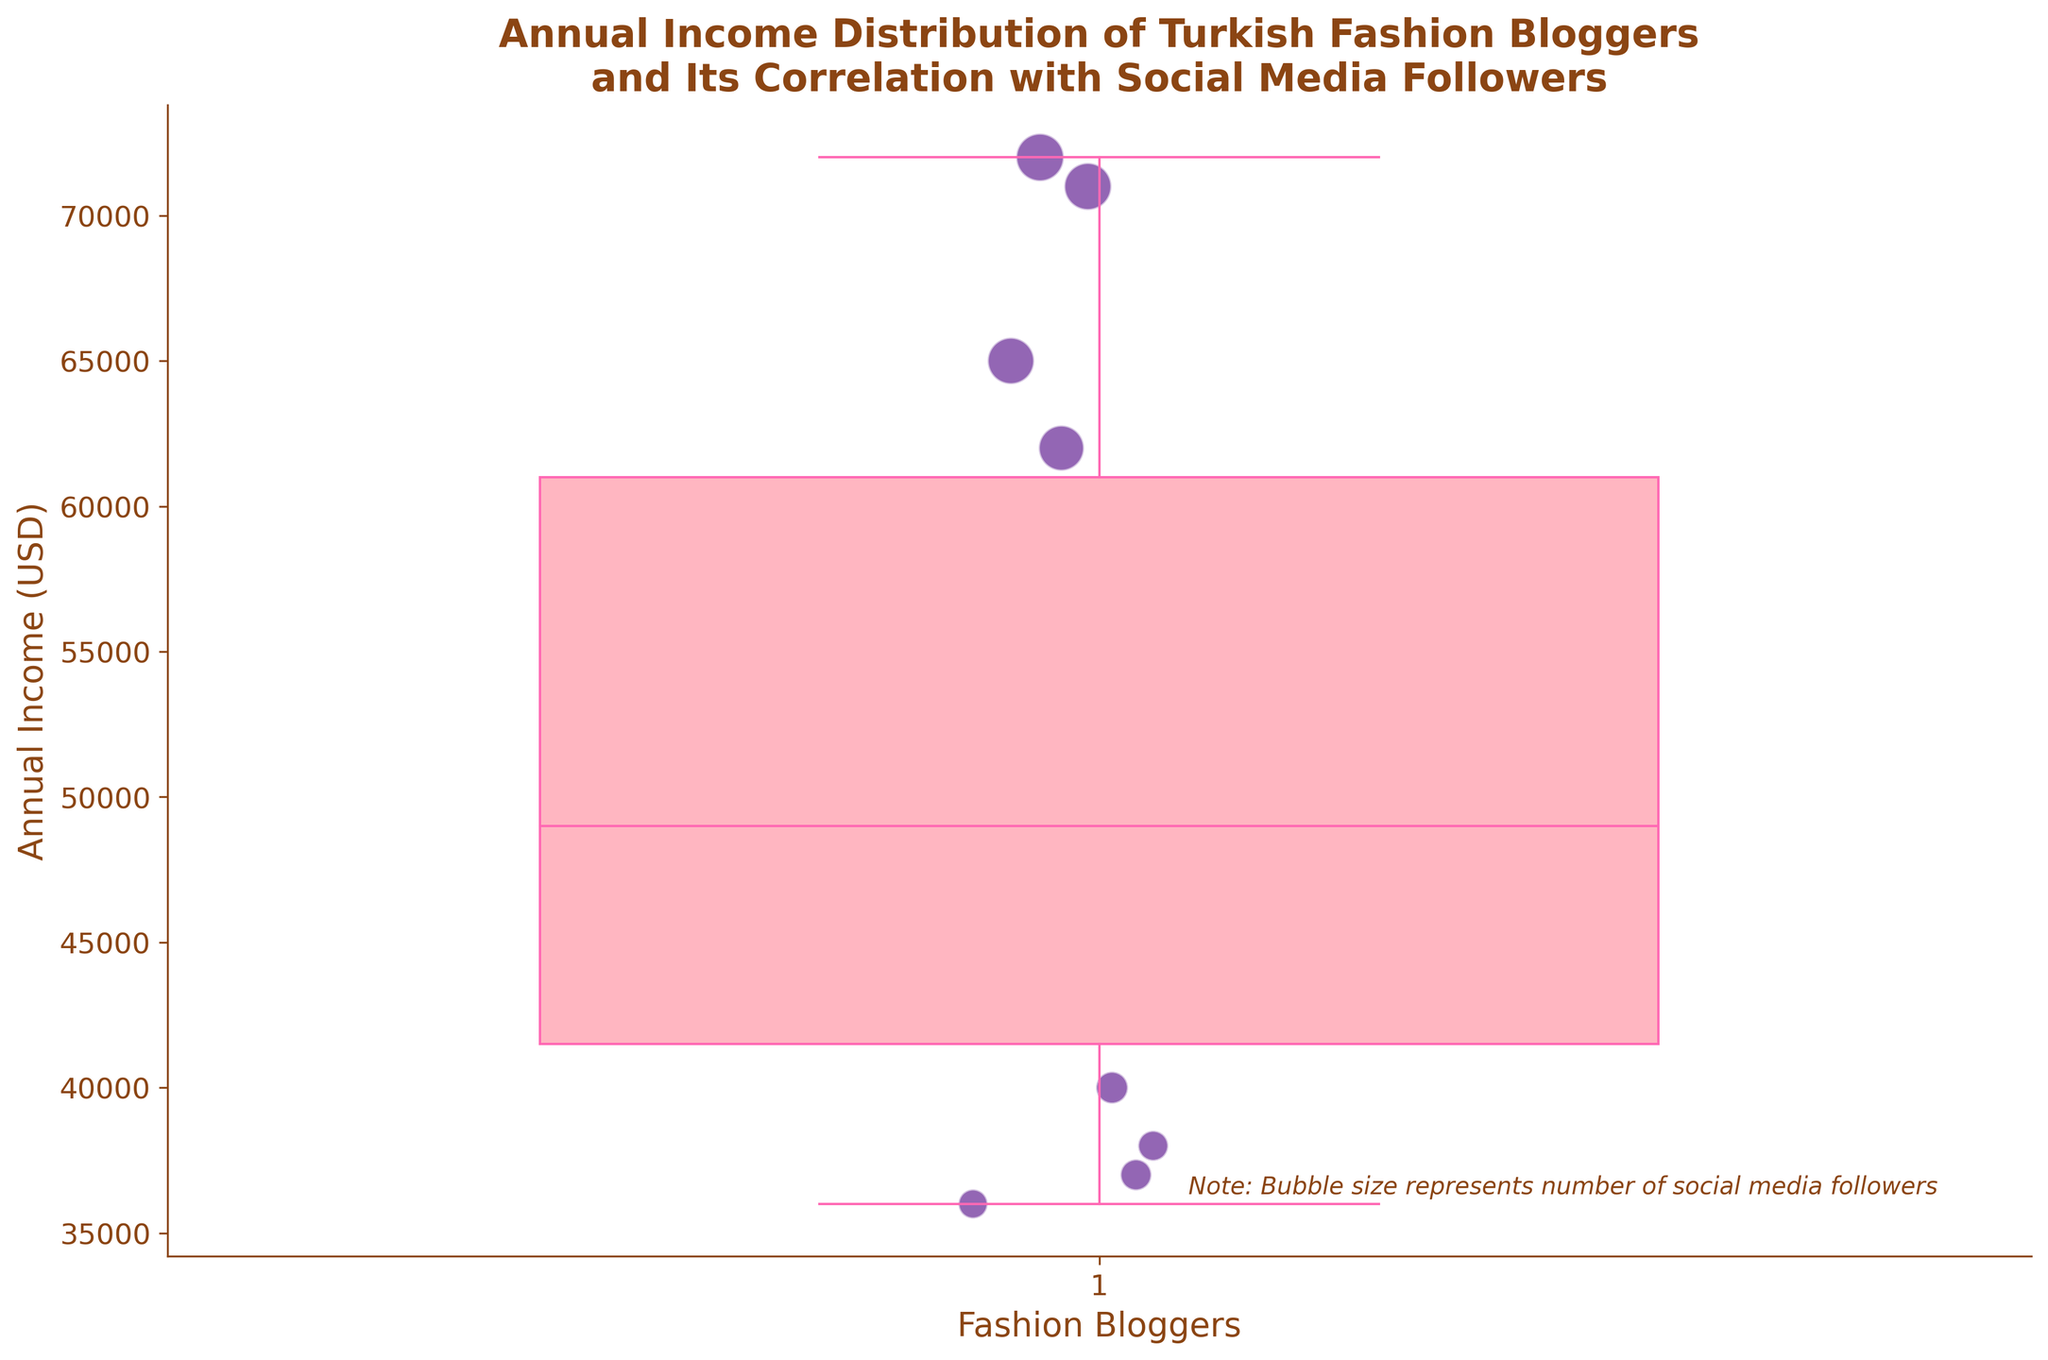What is the title of the plot? The title of the plot is displayed at the top of the figure. It reads "Annual Income Distribution of Turkish Fashion Bloggers and Its Correlation with Social Media Followers."
Answer: Annual Income Distribution of Turkish Fashion Bloggers and Its Correlation with Social Media Followers What color represents the boxes in the box plot? The boxes in the box plot are colored in pink, which is indicated by their shaded areas.
Answer: Pink How many fashion bloggers are represented in the scatter plot? Each fashion blogger corresponds to a scatter point on the figure. By counting these points, one can determine the number of fashion bloggers. There are 15 points in the scatter plot.
Answer: 15 What is the median annual income of the fashion bloggers? The median annual income is indicated by the horizontal line inside the box in the box plot. This line appears at around $50,000.
Answer: $50,000 Which fashion blogger has the highest annual income, and how many followers do they have? By observing the highest point in the scatter plot and matching it to the data, Aylin Celik, with an annual income of $72,000, has the highest income. She has 200,000 followers.
Answer: Aylin Celik, 200,000 followers What is the annual income range (minimum to maximum) of the fashion bloggers? The range is represented by the bottom and top whiskers of the box plot, indicating the minimum and maximum values. The minimum is around $36,000, and the maximum is $72,000.
Answer: $36,000 to $72,000 What is the difference in annual income between the fashion blogger with the most followers and the fashion blogger with the least followers? The bloggers with the most and least followers are Aylin Celik (200,000 followers) with an income of $72,000 and Ayse Karakaya (75,000 followers) with an income of $36,000. The difference is $72,000 - $36,000.
Answer: $36,000 How does the scatter point size reflect the data in the plot? The size of each scatter point is proportional to the number of social media followers of each fashion blogger. Larger points indicate more followers, and smaller points indicate fewer followers.
Answer: Proportional to social media followers Are there any outliers in the data set according to the box plot? Outliers are typically represented by points outside the whiskers, but in this case, there are no such points. Hence, there are no outliers.
Answer: No What can you infer about the correlation between annual income and social media followers among these fashion bloggers? By observing the scatter points, larger points (more followers) tend to be higher up (higher income), indicating a positive correlation between annual income and social media followers.
Answer: Positive correlation 